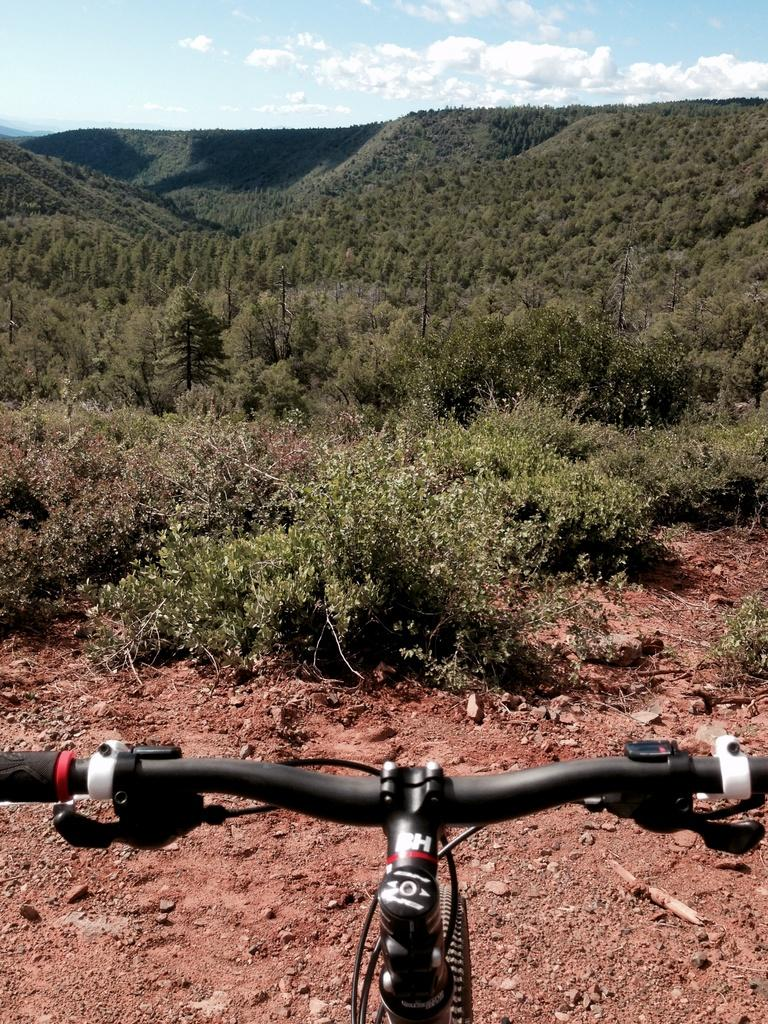What is the main object in the image? There is a bicycle in the image. What can be seen in the background of the image? There are trees and clouds in the sky in the background of the image. How many family members are riding the bicycle in the image? There are no family members present in the image, and the bicycle is not being ridden. What type of cart is attached to the bicycle in the image? There is no cart attached to the bicycle in the image. 